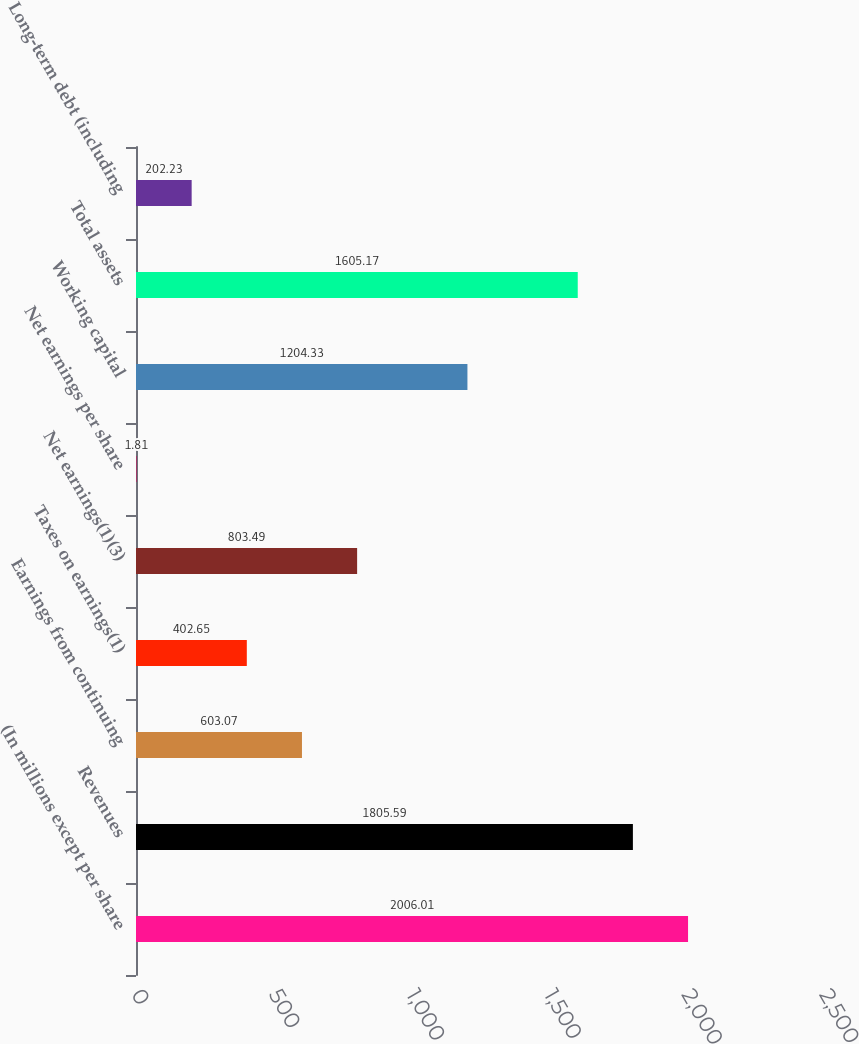Convert chart. <chart><loc_0><loc_0><loc_500><loc_500><bar_chart><fcel>(In millions except per share<fcel>Revenues<fcel>Earnings from continuing<fcel>Taxes on earnings(1)<fcel>Net earnings(1)(3)<fcel>Net earnings per share<fcel>Working capital<fcel>Total assets<fcel>Long-term debt (including<nl><fcel>2006.01<fcel>1805.59<fcel>603.07<fcel>402.65<fcel>803.49<fcel>1.81<fcel>1204.33<fcel>1605.17<fcel>202.23<nl></chart> 